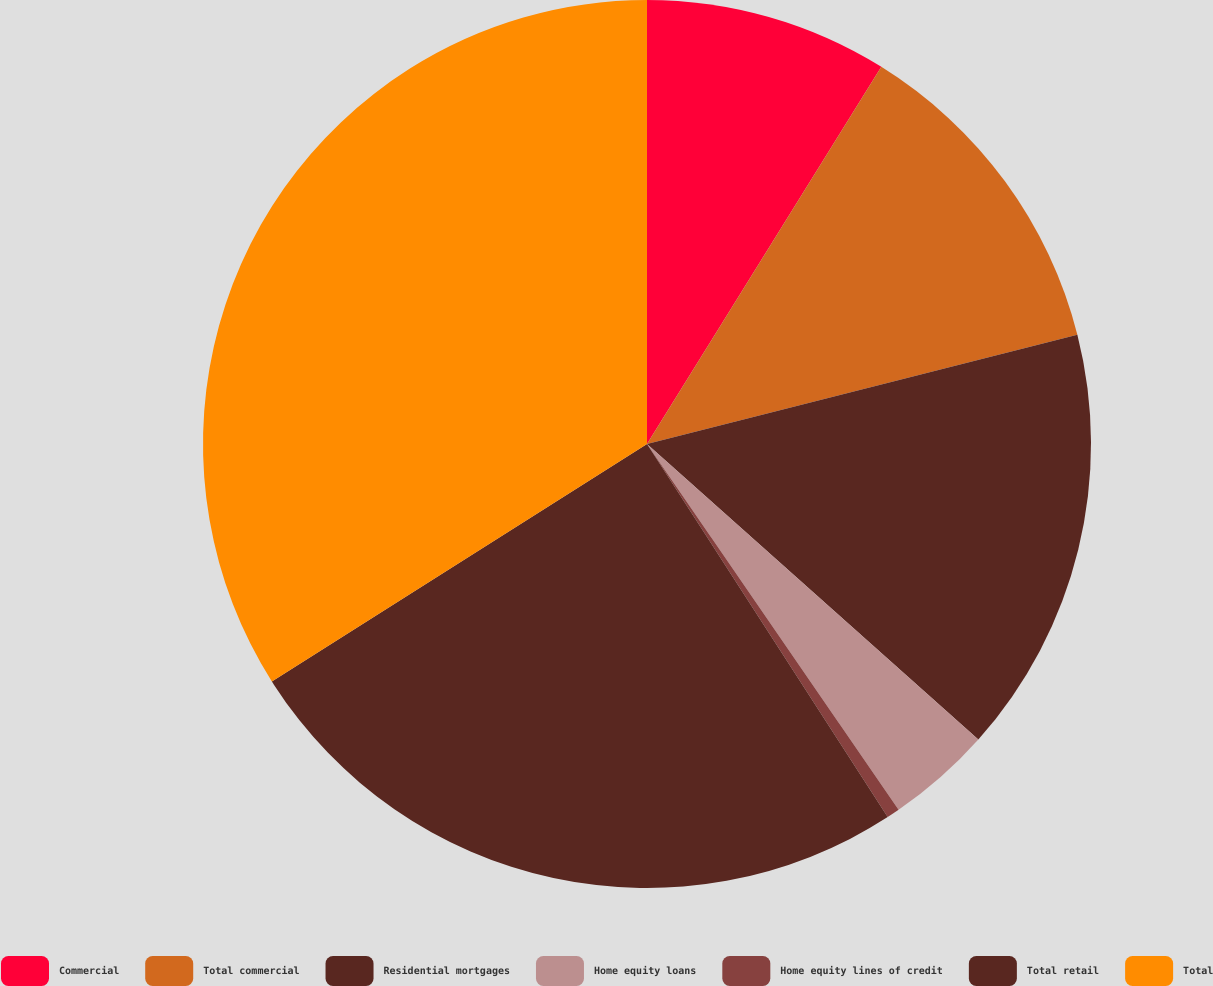Convert chart to OTSL. <chart><loc_0><loc_0><loc_500><loc_500><pie_chart><fcel>Commercial<fcel>Total commercial<fcel>Residential mortgages<fcel>Home equity loans<fcel>Home equity lines of credit<fcel>Total retail<fcel>Total<nl><fcel>8.85%<fcel>12.2%<fcel>15.55%<fcel>3.82%<fcel>0.47%<fcel>25.14%<fcel>33.99%<nl></chart> 